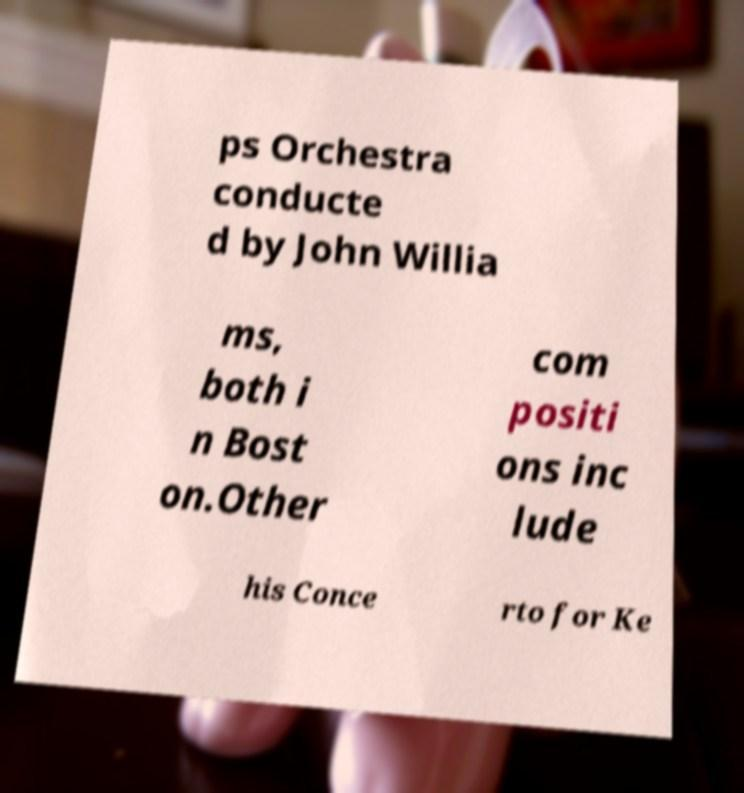Could you extract and type out the text from this image? ps Orchestra conducte d by John Willia ms, both i n Bost on.Other com positi ons inc lude his Conce rto for Ke 